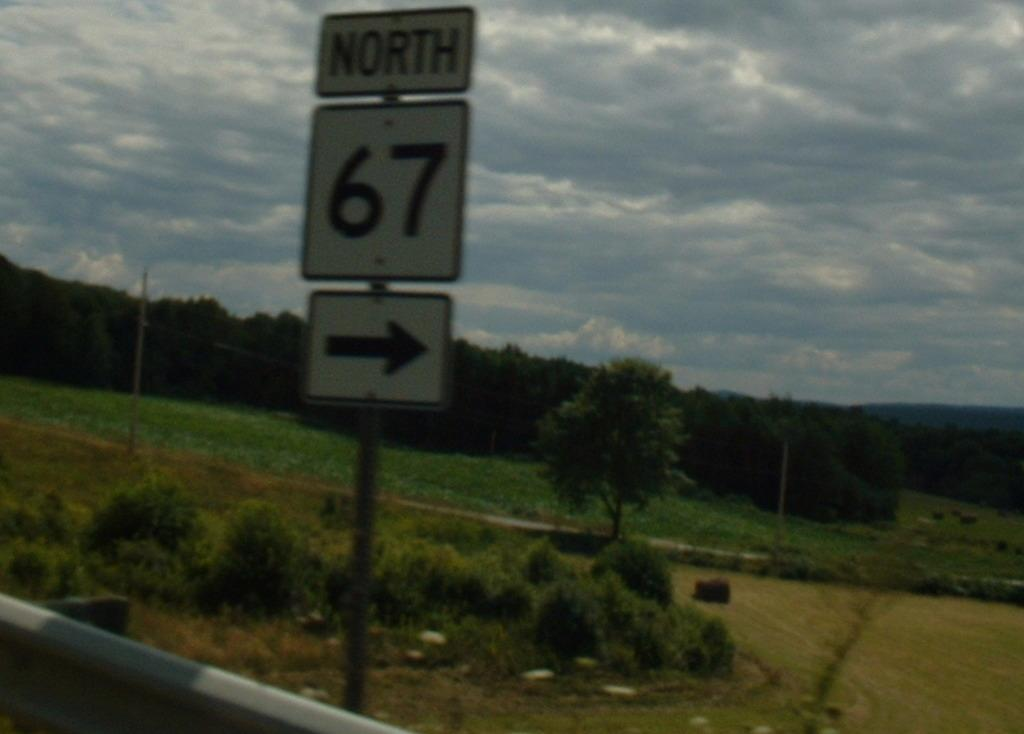<image>
Share a concise interpretation of the image provided. A road sign reading NORTH 67 in front of trees, a meadow, and some scrub. 